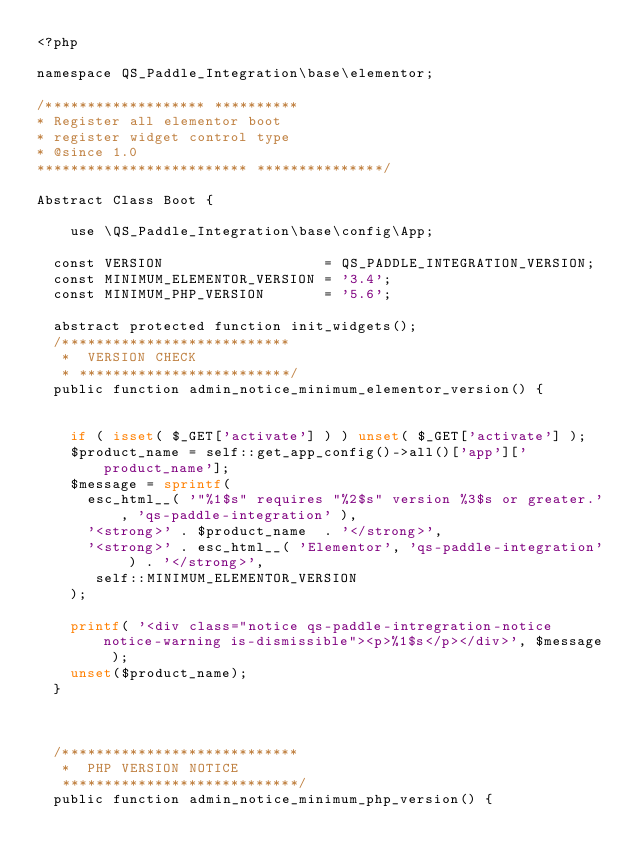<code> <loc_0><loc_0><loc_500><loc_500><_PHP_><?php 

namespace QS_Paddle_Integration\base\elementor;

/******************* **********
* Register all elementor boot
* register widget control type
* @since 1.0 
************************* ***************/
 
Abstract Class Boot {

    use \QS_Paddle_Integration\base\config\App;

	const VERSION                   = QS_PADDLE_INTEGRATION_VERSION;
	const MINIMUM_ELEMENTOR_VERSION = '3.4';
	const MINIMUM_PHP_VERSION       = '5.6';

	abstract protected function init_widgets();
	/***************************
	 * 	VERSION CHECK
	 * *************************/
	public function admin_notice_minimum_elementor_version() {
        

		if ( isset( $_GET['activate'] ) ) unset( $_GET['activate'] );
		$product_name = self::get_app_config()->all()['app']['product_name'];
		$message = sprintf(
			esc_html__( '"%1$s" requires "%2$s" version %3$s or greater.', 'qs-paddle-integration' ),
			'<strong>' . $product_name  . '</strong>',
			'<strong>' . esc_html__( 'Elementor', 'qs-paddle-integration' ) . '</strong>',
			 self::MINIMUM_ELEMENTOR_VERSION
		);

		printf( '<div class="notice qs-paddle-intregration-notice notice-warning is-dismissible"><p>%1$s</p></div>', $message );
		unset($product_name);
	}



	/****************************
	 * 	PHP VERSION NOTICE
	 ****************************/
	public function admin_notice_minimum_php_version() {
</code> 